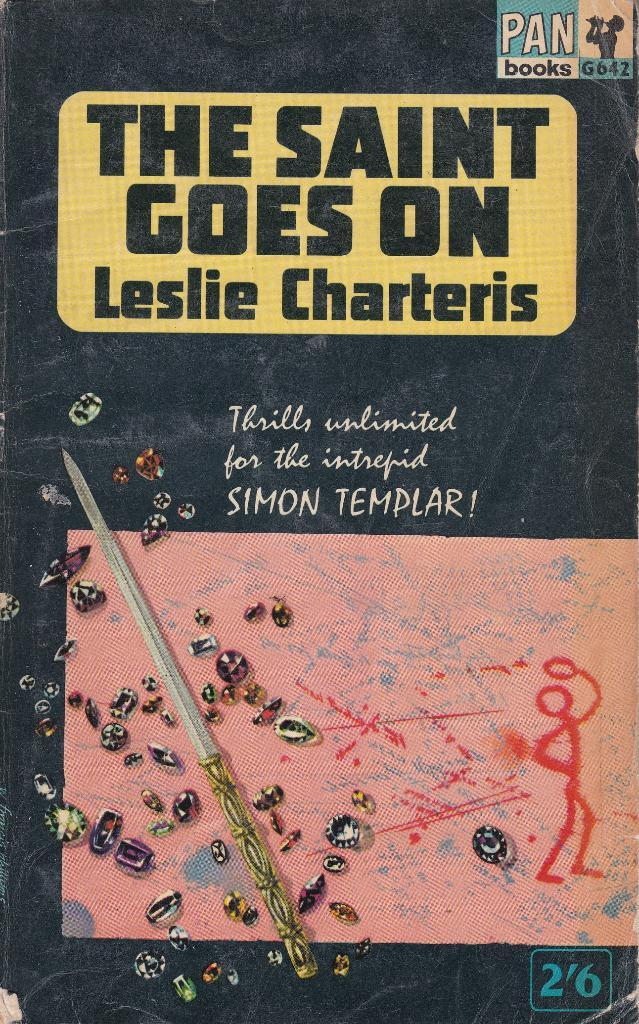<image>
Render a clear and concise summary of the photo. A black book titled The Saint Goes On. 